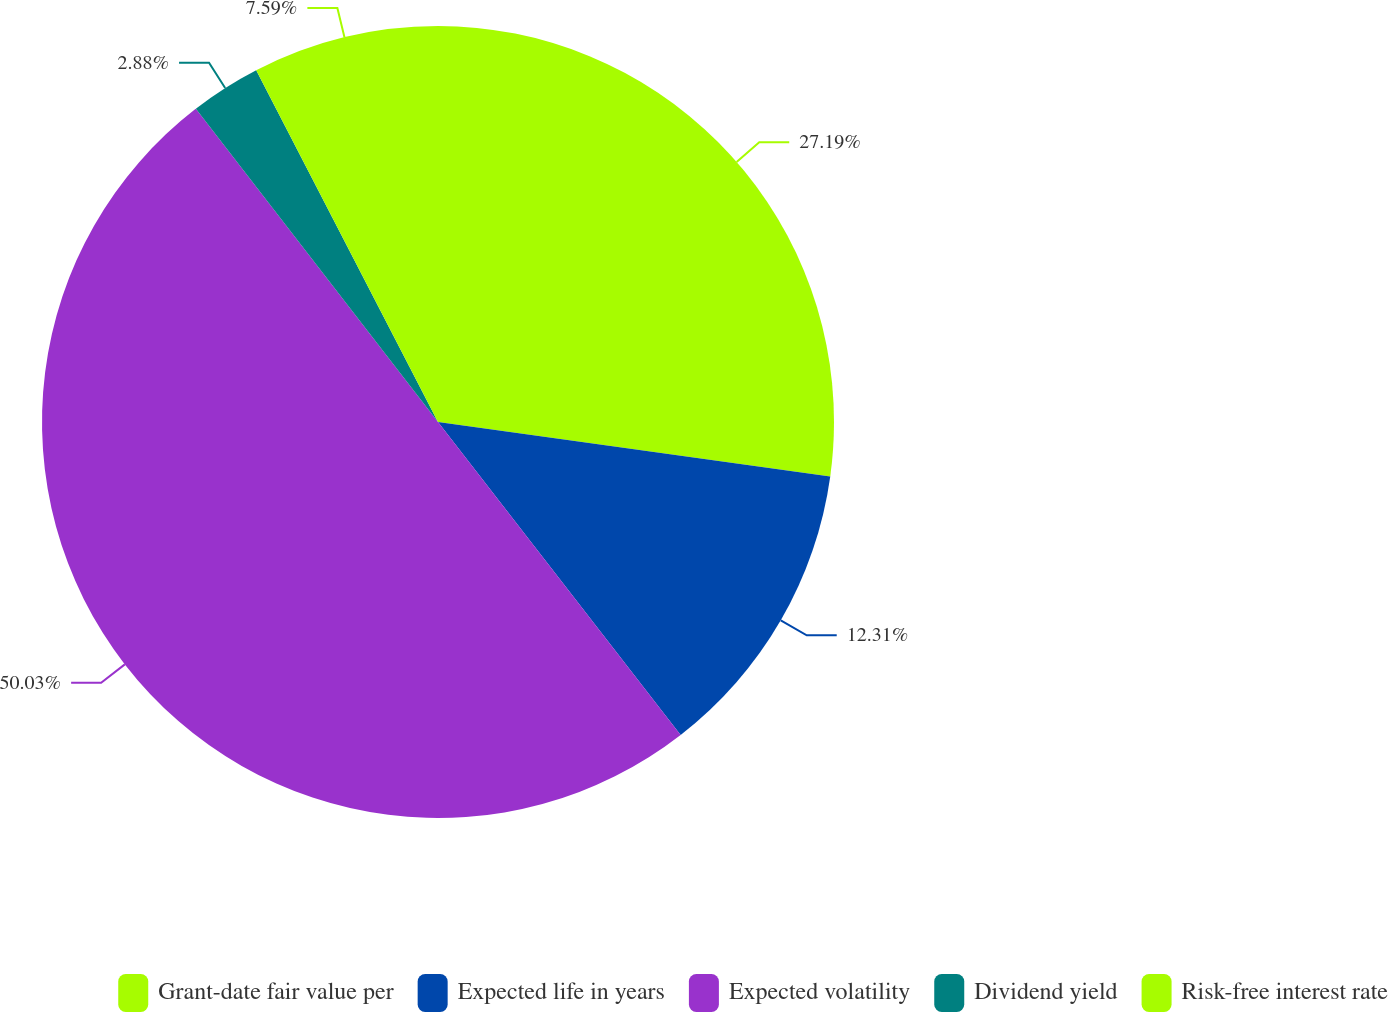Convert chart to OTSL. <chart><loc_0><loc_0><loc_500><loc_500><pie_chart><fcel>Grant-date fair value per<fcel>Expected life in years<fcel>Expected volatility<fcel>Dividend yield<fcel>Risk-free interest rate<nl><fcel>27.19%<fcel>12.31%<fcel>50.02%<fcel>2.88%<fcel>7.59%<nl></chart> 